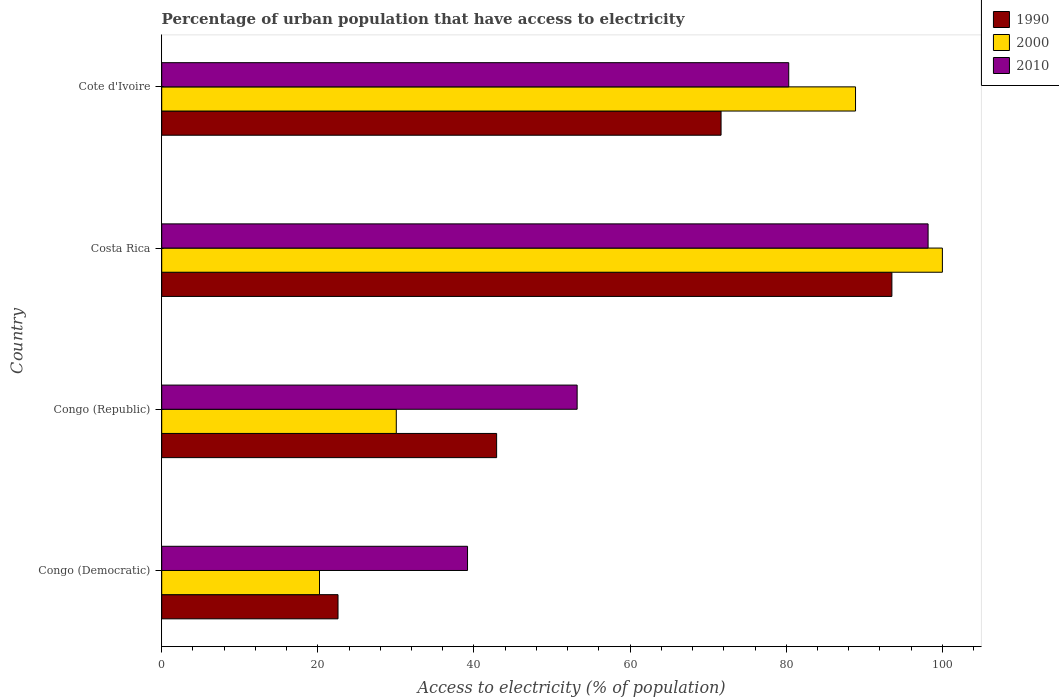How many different coloured bars are there?
Your answer should be compact. 3. Are the number of bars per tick equal to the number of legend labels?
Your answer should be compact. Yes. What is the label of the 1st group of bars from the top?
Offer a terse response. Cote d'Ivoire. In how many cases, is the number of bars for a given country not equal to the number of legend labels?
Make the answer very short. 0. Across all countries, what is the maximum percentage of urban population that have access to electricity in 2010?
Your answer should be compact. 98.17. Across all countries, what is the minimum percentage of urban population that have access to electricity in 1990?
Ensure brevity in your answer.  22.58. In which country was the percentage of urban population that have access to electricity in 1990 minimum?
Your answer should be very brief. Congo (Democratic). What is the total percentage of urban population that have access to electricity in 1990 in the graph?
Your answer should be compact. 230.66. What is the difference between the percentage of urban population that have access to electricity in 1990 in Costa Rica and that in Cote d'Ivoire?
Offer a very short reply. 21.88. What is the difference between the percentage of urban population that have access to electricity in 1990 in Congo (Republic) and the percentage of urban population that have access to electricity in 2000 in Costa Rica?
Provide a succinct answer. -57.1. What is the average percentage of urban population that have access to electricity in 2000 per country?
Provide a succinct answer. 59.78. What is the difference between the percentage of urban population that have access to electricity in 2000 and percentage of urban population that have access to electricity in 1990 in Costa Rica?
Offer a very short reply. 6.47. In how many countries, is the percentage of urban population that have access to electricity in 2000 greater than 20 %?
Make the answer very short. 4. What is the ratio of the percentage of urban population that have access to electricity in 2010 in Congo (Republic) to that in Costa Rica?
Offer a very short reply. 0.54. Is the percentage of urban population that have access to electricity in 2010 in Congo (Democratic) less than that in Cote d'Ivoire?
Offer a very short reply. Yes. What is the difference between the highest and the second highest percentage of urban population that have access to electricity in 2000?
Provide a short and direct response. 11.13. What is the difference between the highest and the lowest percentage of urban population that have access to electricity in 2000?
Offer a very short reply. 79.79. In how many countries, is the percentage of urban population that have access to electricity in 1990 greater than the average percentage of urban population that have access to electricity in 1990 taken over all countries?
Offer a very short reply. 2. What does the 1st bar from the top in Congo (Republic) represents?
Provide a succinct answer. 2010. Is it the case that in every country, the sum of the percentage of urban population that have access to electricity in 1990 and percentage of urban population that have access to electricity in 2000 is greater than the percentage of urban population that have access to electricity in 2010?
Offer a very short reply. Yes. How many countries are there in the graph?
Offer a very short reply. 4. What is the difference between two consecutive major ticks on the X-axis?
Provide a short and direct response. 20. Where does the legend appear in the graph?
Provide a succinct answer. Top right. How many legend labels are there?
Give a very brief answer. 3. What is the title of the graph?
Offer a terse response. Percentage of urban population that have access to electricity. What is the label or title of the X-axis?
Your answer should be very brief. Access to electricity (% of population). What is the Access to electricity (% of population) of 1990 in Congo (Democratic)?
Your response must be concise. 22.58. What is the Access to electricity (% of population) of 2000 in Congo (Democratic)?
Keep it short and to the point. 20.21. What is the Access to electricity (% of population) in 2010 in Congo (Democratic)?
Your answer should be compact. 39.17. What is the Access to electricity (% of population) in 1990 in Congo (Republic)?
Provide a short and direct response. 42.9. What is the Access to electricity (% of population) of 2000 in Congo (Republic)?
Your answer should be very brief. 30.05. What is the Access to electricity (% of population) of 2010 in Congo (Republic)?
Ensure brevity in your answer.  53.21. What is the Access to electricity (% of population) in 1990 in Costa Rica?
Your response must be concise. 93.53. What is the Access to electricity (% of population) of 2010 in Costa Rica?
Offer a very short reply. 98.17. What is the Access to electricity (% of population) in 1990 in Cote d'Ivoire?
Ensure brevity in your answer.  71.65. What is the Access to electricity (% of population) of 2000 in Cote d'Ivoire?
Give a very brief answer. 88.87. What is the Access to electricity (% of population) in 2010 in Cote d'Ivoire?
Offer a terse response. 80.32. Across all countries, what is the maximum Access to electricity (% of population) in 1990?
Your answer should be very brief. 93.53. Across all countries, what is the maximum Access to electricity (% of population) of 2000?
Provide a short and direct response. 100. Across all countries, what is the maximum Access to electricity (% of population) in 2010?
Offer a terse response. 98.17. Across all countries, what is the minimum Access to electricity (% of population) of 1990?
Provide a succinct answer. 22.58. Across all countries, what is the minimum Access to electricity (% of population) of 2000?
Offer a terse response. 20.21. Across all countries, what is the minimum Access to electricity (% of population) in 2010?
Give a very brief answer. 39.17. What is the total Access to electricity (% of population) of 1990 in the graph?
Ensure brevity in your answer.  230.66. What is the total Access to electricity (% of population) in 2000 in the graph?
Offer a terse response. 239.13. What is the total Access to electricity (% of population) in 2010 in the graph?
Keep it short and to the point. 270.87. What is the difference between the Access to electricity (% of population) in 1990 in Congo (Democratic) and that in Congo (Republic)?
Provide a succinct answer. -20.32. What is the difference between the Access to electricity (% of population) in 2000 in Congo (Democratic) and that in Congo (Republic)?
Give a very brief answer. -9.84. What is the difference between the Access to electricity (% of population) of 2010 in Congo (Democratic) and that in Congo (Republic)?
Give a very brief answer. -14.04. What is the difference between the Access to electricity (% of population) in 1990 in Congo (Democratic) and that in Costa Rica?
Ensure brevity in your answer.  -70.95. What is the difference between the Access to electricity (% of population) in 2000 in Congo (Democratic) and that in Costa Rica?
Give a very brief answer. -79.79. What is the difference between the Access to electricity (% of population) of 2010 in Congo (Democratic) and that in Costa Rica?
Your answer should be compact. -58.99. What is the difference between the Access to electricity (% of population) in 1990 in Congo (Democratic) and that in Cote d'Ivoire?
Your answer should be compact. -49.06. What is the difference between the Access to electricity (% of population) of 2000 in Congo (Democratic) and that in Cote d'Ivoire?
Give a very brief answer. -68.66. What is the difference between the Access to electricity (% of population) of 2010 in Congo (Democratic) and that in Cote d'Ivoire?
Your answer should be compact. -41.14. What is the difference between the Access to electricity (% of population) of 1990 in Congo (Republic) and that in Costa Rica?
Offer a terse response. -50.63. What is the difference between the Access to electricity (% of population) in 2000 in Congo (Republic) and that in Costa Rica?
Provide a short and direct response. -69.95. What is the difference between the Access to electricity (% of population) of 2010 in Congo (Republic) and that in Costa Rica?
Your answer should be compact. -44.95. What is the difference between the Access to electricity (% of population) of 1990 in Congo (Republic) and that in Cote d'Ivoire?
Give a very brief answer. -28.75. What is the difference between the Access to electricity (% of population) in 2000 in Congo (Republic) and that in Cote d'Ivoire?
Offer a terse response. -58.83. What is the difference between the Access to electricity (% of population) in 2010 in Congo (Republic) and that in Cote d'Ivoire?
Offer a terse response. -27.1. What is the difference between the Access to electricity (% of population) in 1990 in Costa Rica and that in Cote d'Ivoire?
Provide a succinct answer. 21.88. What is the difference between the Access to electricity (% of population) in 2000 in Costa Rica and that in Cote d'Ivoire?
Your answer should be very brief. 11.13. What is the difference between the Access to electricity (% of population) of 2010 in Costa Rica and that in Cote d'Ivoire?
Provide a succinct answer. 17.85. What is the difference between the Access to electricity (% of population) in 1990 in Congo (Democratic) and the Access to electricity (% of population) in 2000 in Congo (Republic)?
Provide a short and direct response. -7.46. What is the difference between the Access to electricity (% of population) of 1990 in Congo (Democratic) and the Access to electricity (% of population) of 2010 in Congo (Republic)?
Offer a terse response. -30.63. What is the difference between the Access to electricity (% of population) of 2000 in Congo (Democratic) and the Access to electricity (% of population) of 2010 in Congo (Republic)?
Provide a succinct answer. -33. What is the difference between the Access to electricity (% of population) in 1990 in Congo (Democratic) and the Access to electricity (% of population) in 2000 in Costa Rica?
Your answer should be compact. -77.42. What is the difference between the Access to electricity (% of population) of 1990 in Congo (Democratic) and the Access to electricity (% of population) of 2010 in Costa Rica?
Your answer should be very brief. -75.58. What is the difference between the Access to electricity (% of population) in 2000 in Congo (Democratic) and the Access to electricity (% of population) in 2010 in Costa Rica?
Keep it short and to the point. -77.96. What is the difference between the Access to electricity (% of population) in 1990 in Congo (Democratic) and the Access to electricity (% of population) in 2000 in Cote d'Ivoire?
Offer a very short reply. -66.29. What is the difference between the Access to electricity (% of population) of 1990 in Congo (Democratic) and the Access to electricity (% of population) of 2010 in Cote d'Ivoire?
Offer a terse response. -57.73. What is the difference between the Access to electricity (% of population) of 2000 in Congo (Democratic) and the Access to electricity (% of population) of 2010 in Cote d'Ivoire?
Offer a terse response. -60.11. What is the difference between the Access to electricity (% of population) of 1990 in Congo (Republic) and the Access to electricity (% of population) of 2000 in Costa Rica?
Offer a terse response. -57.1. What is the difference between the Access to electricity (% of population) of 1990 in Congo (Republic) and the Access to electricity (% of population) of 2010 in Costa Rica?
Ensure brevity in your answer.  -55.27. What is the difference between the Access to electricity (% of population) in 2000 in Congo (Republic) and the Access to electricity (% of population) in 2010 in Costa Rica?
Provide a short and direct response. -68.12. What is the difference between the Access to electricity (% of population) of 1990 in Congo (Republic) and the Access to electricity (% of population) of 2000 in Cote d'Ivoire?
Ensure brevity in your answer.  -45.97. What is the difference between the Access to electricity (% of population) of 1990 in Congo (Republic) and the Access to electricity (% of population) of 2010 in Cote d'Ivoire?
Offer a very short reply. -37.42. What is the difference between the Access to electricity (% of population) of 2000 in Congo (Republic) and the Access to electricity (% of population) of 2010 in Cote d'Ivoire?
Give a very brief answer. -50.27. What is the difference between the Access to electricity (% of population) in 1990 in Costa Rica and the Access to electricity (% of population) in 2000 in Cote d'Ivoire?
Give a very brief answer. 4.66. What is the difference between the Access to electricity (% of population) of 1990 in Costa Rica and the Access to electricity (% of population) of 2010 in Cote d'Ivoire?
Provide a succinct answer. 13.21. What is the difference between the Access to electricity (% of population) in 2000 in Costa Rica and the Access to electricity (% of population) in 2010 in Cote d'Ivoire?
Provide a short and direct response. 19.68. What is the average Access to electricity (% of population) of 1990 per country?
Offer a very short reply. 57.67. What is the average Access to electricity (% of population) of 2000 per country?
Provide a short and direct response. 59.78. What is the average Access to electricity (% of population) in 2010 per country?
Your answer should be very brief. 67.72. What is the difference between the Access to electricity (% of population) in 1990 and Access to electricity (% of population) in 2000 in Congo (Democratic)?
Offer a very short reply. 2.37. What is the difference between the Access to electricity (% of population) in 1990 and Access to electricity (% of population) in 2010 in Congo (Democratic)?
Provide a succinct answer. -16.59. What is the difference between the Access to electricity (% of population) of 2000 and Access to electricity (% of population) of 2010 in Congo (Democratic)?
Your response must be concise. -18.96. What is the difference between the Access to electricity (% of population) in 1990 and Access to electricity (% of population) in 2000 in Congo (Republic)?
Offer a terse response. 12.85. What is the difference between the Access to electricity (% of population) of 1990 and Access to electricity (% of population) of 2010 in Congo (Republic)?
Make the answer very short. -10.31. What is the difference between the Access to electricity (% of population) of 2000 and Access to electricity (% of population) of 2010 in Congo (Republic)?
Keep it short and to the point. -23.16. What is the difference between the Access to electricity (% of population) in 1990 and Access to electricity (% of population) in 2000 in Costa Rica?
Give a very brief answer. -6.47. What is the difference between the Access to electricity (% of population) of 1990 and Access to electricity (% of population) of 2010 in Costa Rica?
Offer a very short reply. -4.64. What is the difference between the Access to electricity (% of population) in 2000 and Access to electricity (% of population) in 2010 in Costa Rica?
Make the answer very short. 1.83. What is the difference between the Access to electricity (% of population) in 1990 and Access to electricity (% of population) in 2000 in Cote d'Ivoire?
Offer a very short reply. -17.23. What is the difference between the Access to electricity (% of population) in 1990 and Access to electricity (% of population) in 2010 in Cote d'Ivoire?
Provide a short and direct response. -8.67. What is the difference between the Access to electricity (% of population) in 2000 and Access to electricity (% of population) in 2010 in Cote d'Ivoire?
Keep it short and to the point. 8.56. What is the ratio of the Access to electricity (% of population) of 1990 in Congo (Democratic) to that in Congo (Republic)?
Your answer should be very brief. 0.53. What is the ratio of the Access to electricity (% of population) in 2000 in Congo (Democratic) to that in Congo (Republic)?
Make the answer very short. 0.67. What is the ratio of the Access to electricity (% of population) in 2010 in Congo (Democratic) to that in Congo (Republic)?
Ensure brevity in your answer.  0.74. What is the ratio of the Access to electricity (% of population) of 1990 in Congo (Democratic) to that in Costa Rica?
Ensure brevity in your answer.  0.24. What is the ratio of the Access to electricity (% of population) in 2000 in Congo (Democratic) to that in Costa Rica?
Offer a very short reply. 0.2. What is the ratio of the Access to electricity (% of population) in 2010 in Congo (Democratic) to that in Costa Rica?
Provide a short and direct response. 0.4. What is the ratio of the Access to electricity (% of population) in 1990 in Congo (Democratic) to that in Cote d'Ivoire?
Give a very brief answer. 0.32. What is the ratio of the Access to electricity (% of population) in 2000 in Congo (Democratic) to that in Cote d'Ivoire?
Ensure brevity in your answer.  0.23. What is the ratio of the Access to electricity (% of population) in 2010 in Congo (Democratic) to that in Cote d'Ivoire?
Ensure brevity in your answer.  0.49. What is the ratio of the Access to electricity (% of population) in 1990 in Congo (Republic) to that in Costa Rica?
Give a very brief answer. 0.46. What is the ratio of the Access to electricity (% of population) in 2000 in Congo (Republic) to that in Costa Rica?
Give a very brief answer. 0.3. What is the ratio of the Access to electricity (% of population) in 2010 in Congo (Republic) to that in Costa Rica?
Your response must be concise. 0.54. What is the ratio of the Access to electricity (% of population) of 1990 in Congo (Republic) to that in Cote d'Ivoire?
Your answer should be very brief. 0.6. What is the ratio of the Access to electricity (% of population) of 2000 in Congo (Republic) to that in Cote d'Ivoire?
Your answer should be very brief. 0.34. What is the ratio of the Access to electricity (% of population) in 2010 in Congo (Republic) to that in Cote d'Ivoire?
Give a very brief answer. 0.66. What is the ratio of the Access to electricity (% of population) in 1990 in Costa Rica to that in Cote d'Ivoire?
Make the answer very short. 1.31. What is the ratio of the Access to electricity (% of population) of 2000 in Costa Rica to that in Cote d'Ivoire?
Provide a short and direct response. 1.13. What is the ratio of the Access to electricity (% of population) in 2010 in Costa Rica to that in Cote d'Ivoire?
Give a very brief answer. 1.22. What is the difference between the highest and the second highest Access to electricity (% of population) of 1990?
Provide a short and direct response. 21.88. What is the difference between the highest and the second highest Access to electricity (% of population) in 2000?
Make the answer very short. 11.13. What is the difference between the highest and the second highest Access to electricity (% of population) of 2010?
Keep it short and to the point. 17.85. What is the difference between the highest and the lowest Access to electricity (% of population) of 1990?
Provide a succinct answer. 70.95. What is the difference between the highest and the lowest Access to electricity (% of population) of 2000?
Your answer should be very brief. 79.79. What is the difference between the highest and the lowest Access to electricity (% of population) in 2010?
Keep it short and to the point. 58.99. 